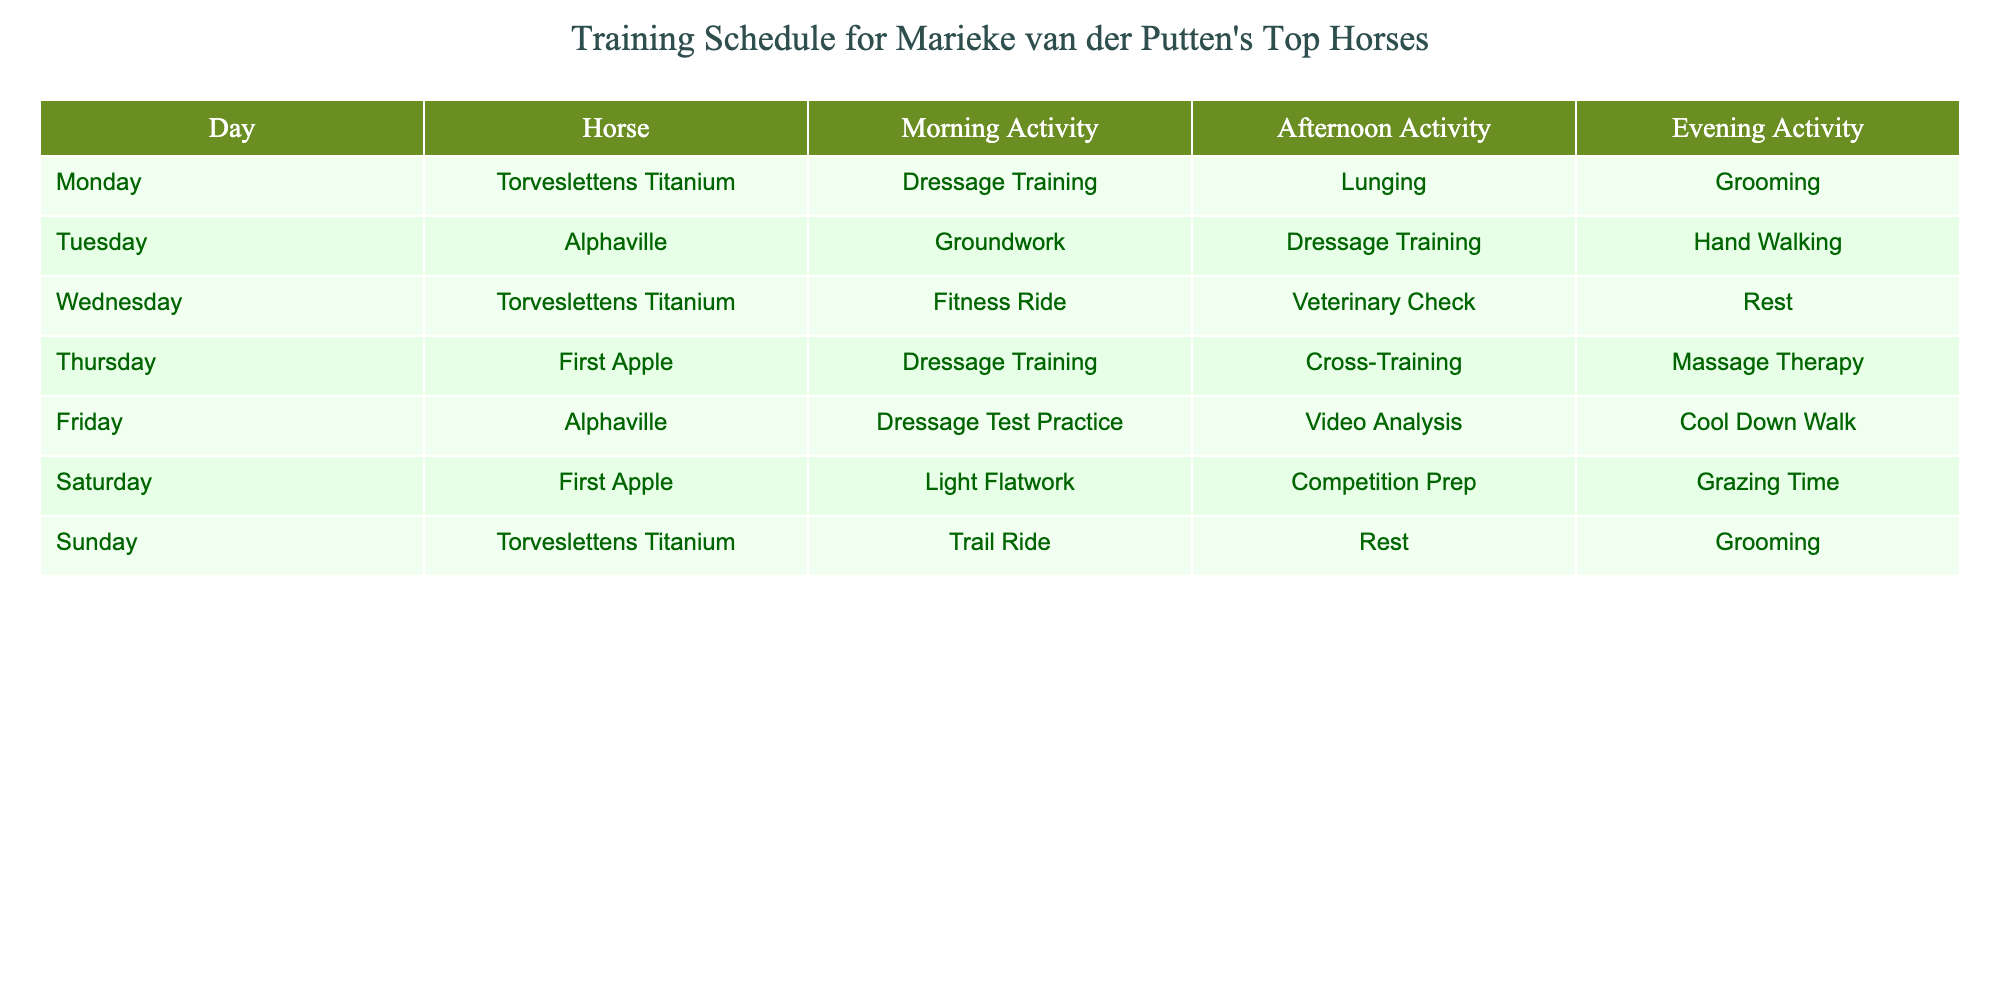What activities does Torveslettens Titanium engage in on Monday? On Monday, Torveslettens Titanium participates in Dressage Training in the morning, lunging in the afternoon, and grooming in the evening.
Answer: Dressage Training, Lunging, Grooming How many horses participate in Dressage Training throughout the week? Torveslettens Titanium, Alphaville, and First Apple all have Dressage Training scheduled, summing up to three horses participating in this activity.
Answer: 3 Which horse has the most varied activities throughout the week? If we analyze the activities for each horse, Torveslettens Titanium has a fitness ride, a veterinary check, a trail ride, and more, indicating a wider range of activities.
Answer: Torveslettens Titanium On which day does First Apple have Competition Prep? First Apple has Competition Prep on Saturday afternoon according to the schedule in the table.
Answer: Saturday Does Alphaville participate in any activities on Sunday? According to the table, Alphaville does not have any activities scheduled on Sunday.
Answer: No Which horse has a rest day and what day is it? Torveslettens Titanium has a rest day on Wednesday, where no activities are scheduled for the afternoon or evening.
Answer: Wednesday How does the total number of activities for Torveslettens Titanium compare to Alphaville's over the week? Torveslettens Titanium has a total of 6 activities (3 in morning, 2 in afternoon, and 1 in evening) while Alphaville has 6 activities as well (2 in morning, 2 in afternoon, and 2 in evening). They are equal.
Answer: Equal What is the main focus of the training activities for First Apple? First Apple's training activities include Dressage Training and Cross-Training, indicating a focus primarily on dressage and conditioning.
Answer: Dressage and Cross-Training Is there any day where all horses have a rest activity? Analyzing the table, there is no single day where all horses are scheduled for a rest activity; they are staggered throughout the week.
Answer: No Which horse does not participate in any fitness-related activity? First Apple does not participate in any fitness-related activities, as its schedule includes dressage and cross-training instead.
Answer: First Apple 